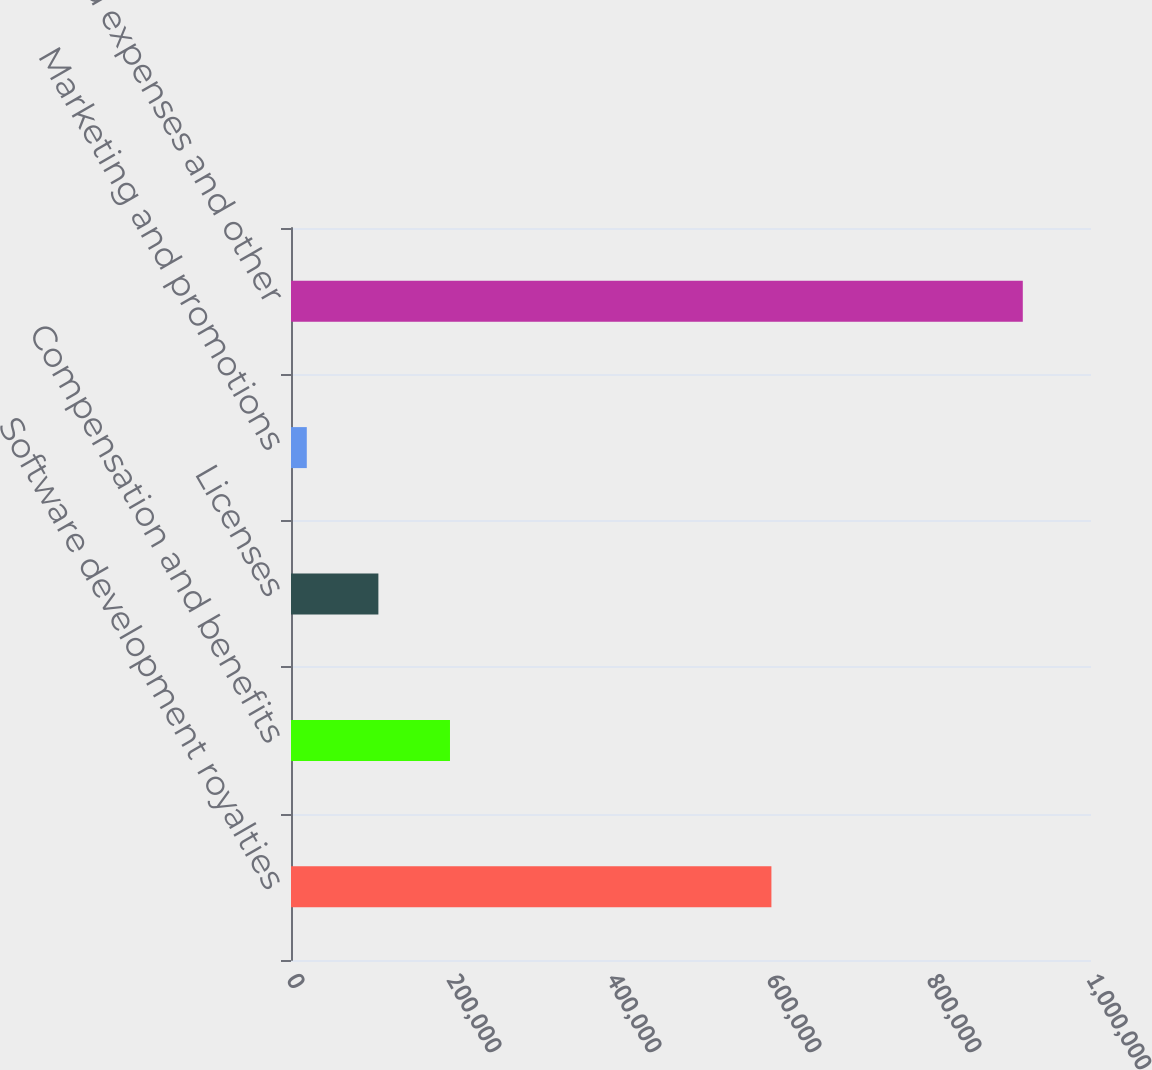<chart> <loc_0><loc_0><loc_500><loc_500><bar_chart><fcel>Software development royalties<fcel>Compensation and benefits<fcel>Licenses<fcel>Marketing and promotions<fcel>Accrued expenses and other<nl><fcel>600512<fcel>198734<fcel>109233<fcel>19731<fcel>914748<nl></chart> 